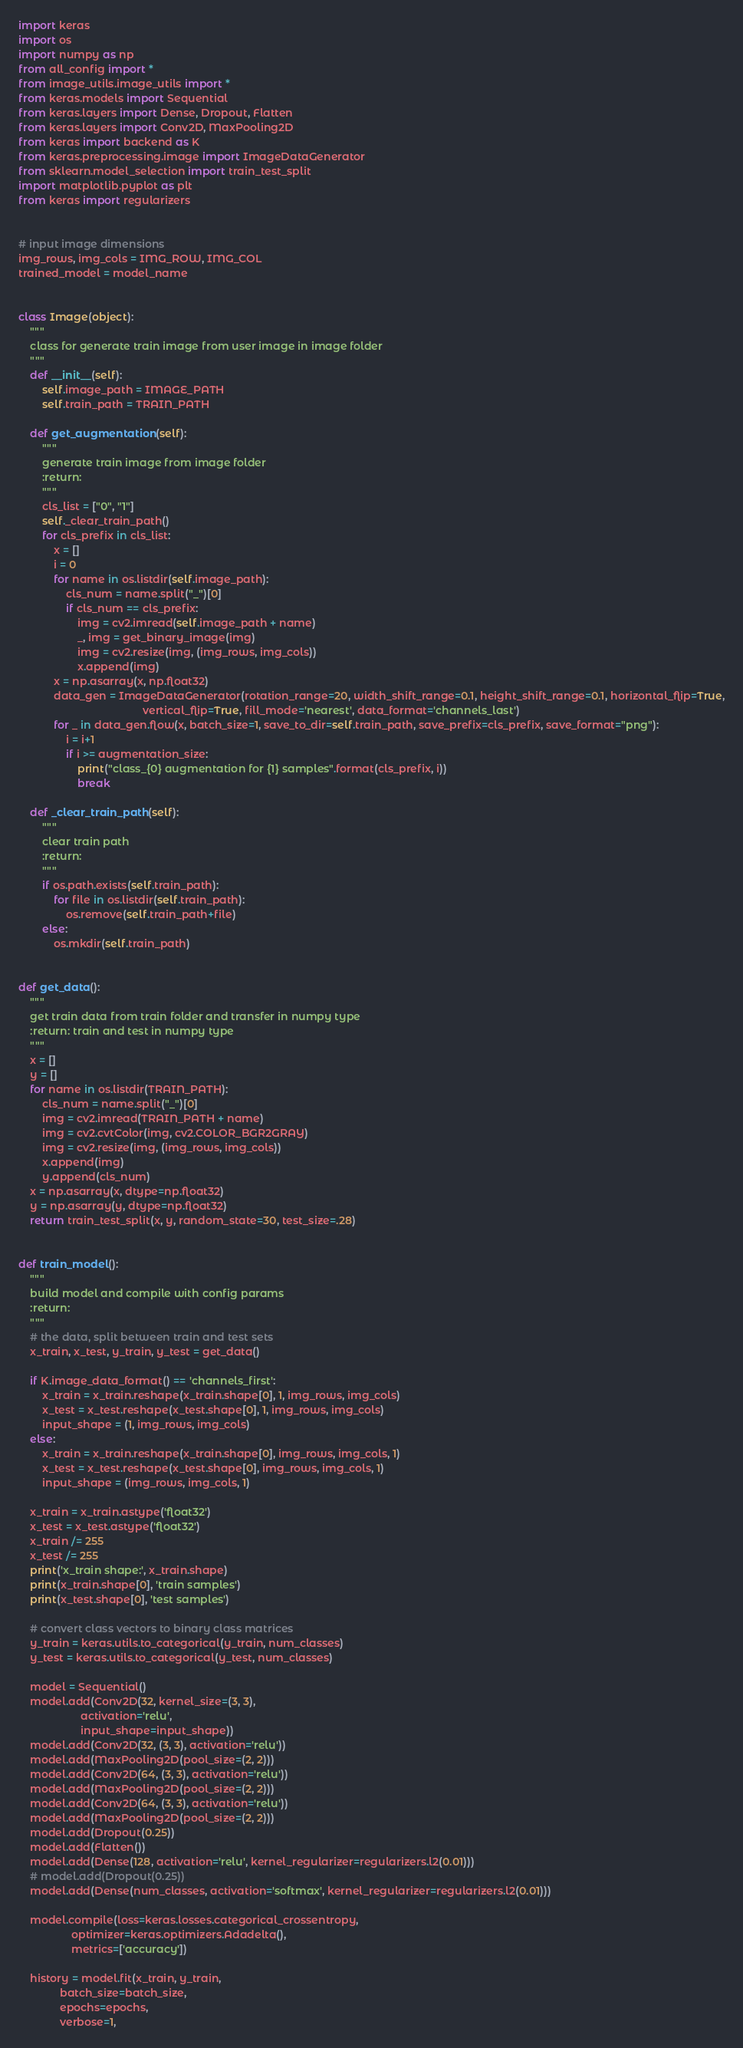Convert code to text. <code><loc_0><loc_0><loc_500><loc_500><_Python_>import keras
import os
import numpy as np
from all_config import *
from image_utils.image_utils import *
from keras.models import Sequential
from keras.layers import Dense, Dropout, Flatten
from keras.layers import Conv2D, MaxPooling2D
from keras import backend as K
from keras.preprocessing.image import ImageDataGenerator
from sklearn.model_selection import train_test_split
import matplotlib.pyplot as plt
from keras import regularizers


# input image dimensions
img_rows, img_cols = IMG_ROW, IMG_COL
trained_model = model_name


class Image(object):
    """
    class for generate train image from user image in image folder
    """
    def __init__(self):
        self.image_path = IMAGE_PATH
        self.train_path = TRAIN_PATH

    def get_augmentation(self):
        """
        generate train image from image folder
        :return:
        """
        cls_list = ["0", "1"]
        self._clear_train_path()
        for cls_prefix in cls_list:
            x = []
            i = 0
            for name in os.listdir(self.image_path):
                cls_num = name.split("_")[0]
                if cls_num == cls_prefix:
                    img = cv2.imread(self.image_path + name)
                    _, img = get_binary_image(img)
                    img = cv2.resize(img, (img_rows, img_cols))
                    x.append(img)
            x = np.asarray(x, np.float32)
            data_gen = ImageDataGenerator(rotation_range=20, width_shift_range=0.1, height_shift_range=0.1, horizontal_flip=True,
                                          vertical_flip=True, fill_mode='nearest', data_format='channels_last')
            for _ in data_gen.flow(x, batch_size=1, save_to_dir=self.train_path, save_prefix=cls_prefix, save_format="png"):
                i = i+1
                if i >= augmentation_size:
                    print("class_{0} augmentation for {1} samples".format(cls_prefix, i))
                    break

    def _clear_train_path(self):
        """
        clear train path
        :return:
        """
        if os.path.exists(self.train_path):
            for file in os.listdir(self.train_path):
                os.remove(self.train_path+file)
        else:
            os.mkdir(self.train_path)


def get_data():
    """
    get train data from train folder and transfer in numpy type
    :return: train and test in numpy type
    """
    x = []
    y = []
    for name in os.listdir(TRAIN_PATH):
        cls_num = name.split("_")[0]
        img = cv2.imread(TRAIN_PATH + name)
        img = cv2.cvtColor(img, cv2.COLOR_BGR2GRAY)
        img = cv2.resize(img, (img_rows, img_cols))
        x.append(img)
        y.append(cls_num)
    x = np.asarray(x, dtype=np.float32)
    y = np.asarray(y, dtype=np.float32)
    return train_test_split(x, y, random_state=30, test_size=.28)


def train_model():
    """
    build model and compile with config params
    :return:
    """
    # the data, split between train and test sets
    x_train, x_test, y_train, y_test = get_data()

    if K.image_data_format() == 'channels_first':
        x_train = x_train.reshape(x_train.shape[0], 1, img_rows, img_cols)
        x_test = x_test.reshape(x_test.shape[0], 1, img_rows, img_cols)
        input_shape = (1, img_rows, img_cols)
    else:
        x_train = x_train.reshape(x_train.shape[0], img_rows, img_cols, 1)
        x_test = x_test.reshape(x_test.shape[0], img_rows, img_cols, 1)
        input_shape = (img_rows, img_cols, 1)

    x_train = x_train.astype('float32')
    x_test = x_test.astype('float32')
    x_train /= 255
    x_test /= 255
    print('x_train shape:', x_train.shape)
    print(x_train.shape[0], 'train samples')
    print(x_test.shape[0], 'test samples')

    # convert class vectors to binary class matrices
    y_train = keras.utils.to_categorical(y_train, num_classes)
    y_test = keras.utils.to_categorical(y_test, num_classes)

    model = Sequential()
    model.add(Conv2D(32, kernel_size=(3, 3),
                     activation='relu',
                     input_shape=input_shape))
    model.add(Conv2D(32, (3, 3), activation='relu'))
    model.add(MaxPooling2D(pool_size=(2, 2)))
    model.add(Conv2D(64, (3, 3), activation='relu'))
    model.add(MaxPooling2D(pool_size=(2, 2)))
    model.add(Conv2D(64, (3, 3), activation='relu'))
    model.add(MaxPooling2D(pool_size=(2, 2)))
    model.add(Dropout(0.25))
    model.add(Flatten())
    model.add(Dense(128, activation='relu', kernel_regularizer=regularizers.l2(0.01)))
    # model.add(Dropout(0.25))
    model.add(Dense(num_classes, activation='softmax', kernel_regularizer=regularizers.l2(0.01)))

    model.compile(loss=keras.losses.categorical_crossentropy,
                  optimizer=keras.optimizers.Adadelta(),
                  metrics=['accuracy'])

    history = model.fit(x_train, y_train,
              batch_size=batch_size,
              epochs=epochs,
              verbose=1,</code> 